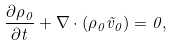Convert formula to latex. <formula><loc_0><loc_0><loc_500><loc_500>\frac { \partial { \rho } _ { 0 } } { \partial t } + \nabla \cdot ( \rho _ { 0 } \vec { v } _ { 0 } ) = 0 ,</formula> 